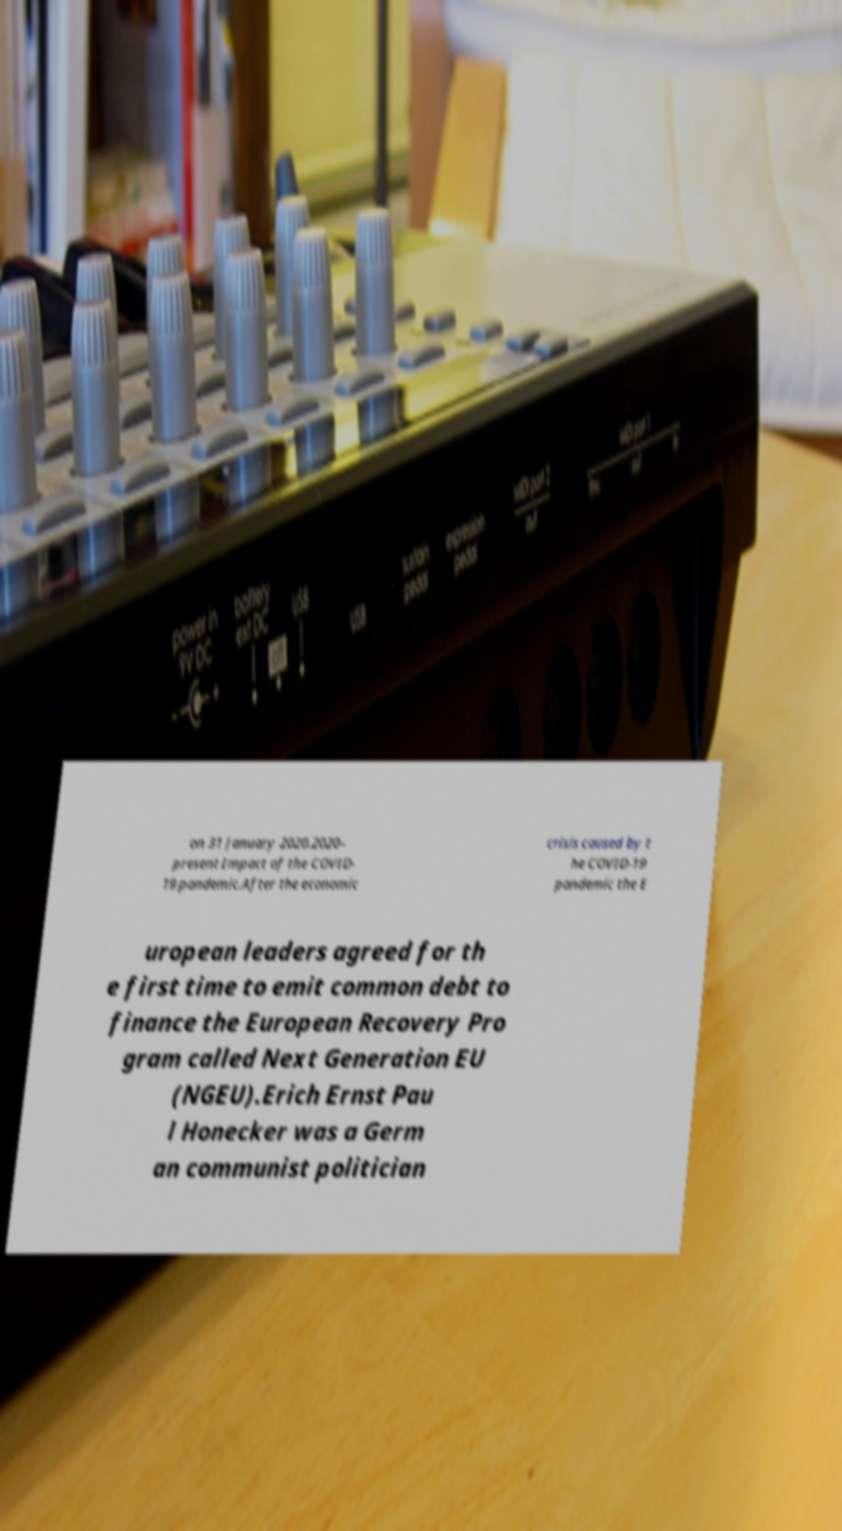Can you accurately transcribe the text from the provided image for me? on 31 January 2020.2020– present Impact of the COVID- 19 pandemic.After the economic crisis caused by t he COVID-19 pandemic the E uropean leaders agreed for th e first time to emit common debt to finance the European Recovery Pro gram called Next Generation EU (NGEU).Erich Ernst Pau l Honecker was a Germ an communist politician 